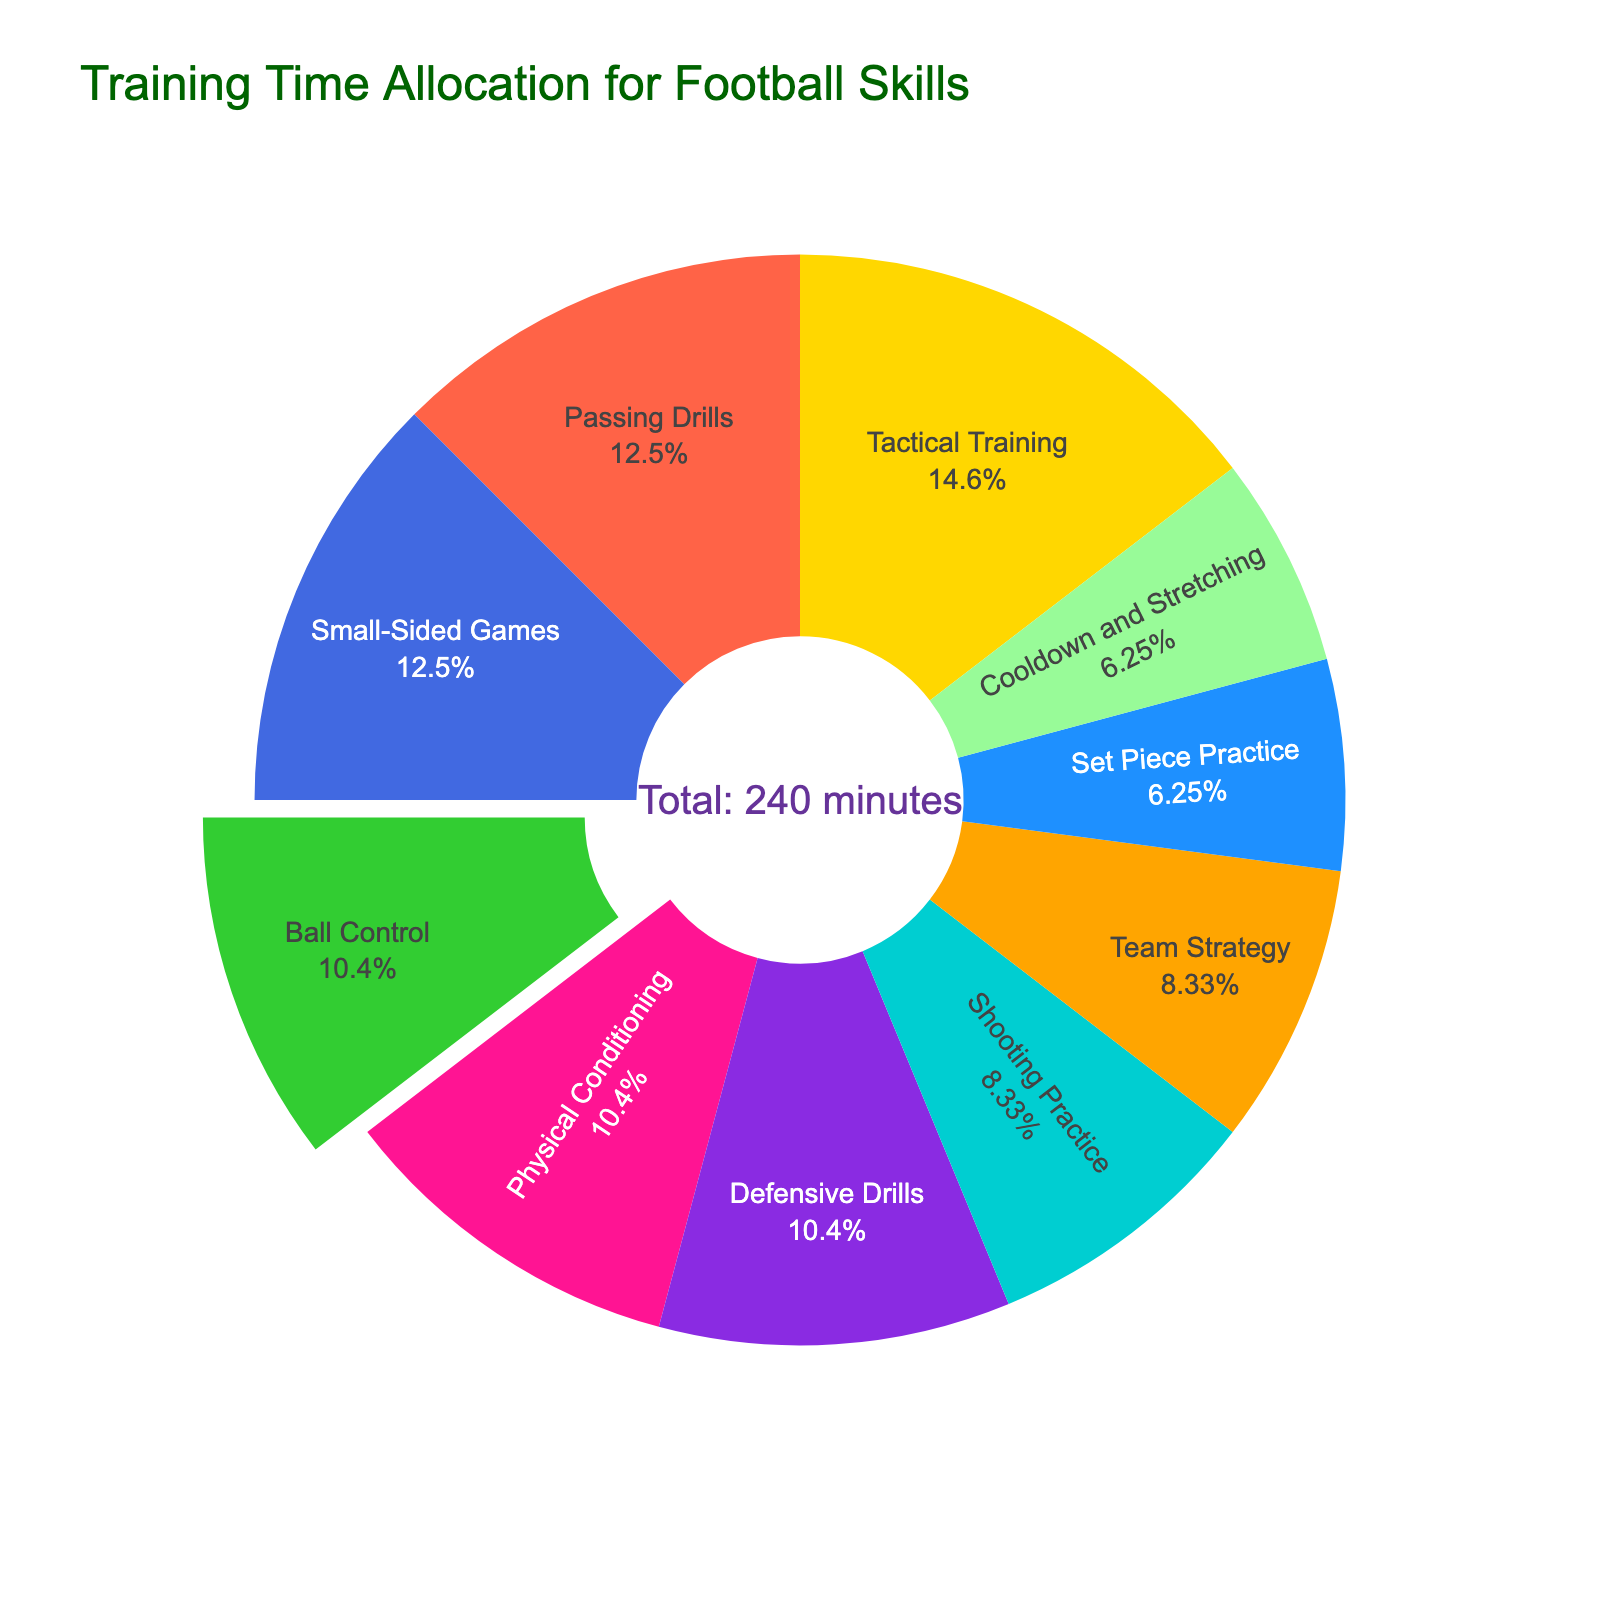Which skill has the highest allocation time? By observing the chart, the segment with the biggest area represents the skill with the highest time allocation.
Answer: Tactical Training Which two skills have equal time allocation? Looking at the chart, we observe segments of equal size corresponding to the skills of Ball Control and Defensive Drills.
Answer: Ball Control and Defensive Drills What's the total time allocated for Shooting Practice and Team Strategy? From the chart, Shooting Practice is 20 minutes and Team Strategy is 20 minutes. Summing them gives us 20 + 20 = 40 minutes.
Answer: 40 minutes How does the time allocated for Passing Drills compare to Small-Sided Games? Referring to the chart, we see the allocated time for both Passing Drills and Small-Sided Games is 30 minutes each.
Answer: Equal What percentage of training time is spent on Physical Conditioning? The chart segments denote the percentage of total time for each skill. The Physical Conditioning segment displays its percentage as part of the whole.
Answer: 10.4% What is the second least allocated skill? The chart's segment proportions identify Set Piece Practice and Cooldown and Stretching as the smallest. Among them, Set Piece Practice is higher than Cooldown and Stretching but lower than the other skills.
Answer: Cooldown and Stretching Compare the total time allocated for Ball Control and Defensive Drills with the time allocated for Tactical Training. Ball Control and Defensive Drills both have 25 minutes each, summing up to 50 minutes. Tactical Training has 35 minutes. Hence, 50 minutes (Ball Control + Defensive Drills) is greater than 35 minutes (Tactical Training).
Answer: Ball Control and Defensive Drills: 50 minutes > Tactical Training: 35 minutes Which skill is allocated 10.4% of the total training time? From the chart, noting the percentage display inside each segment, we find Physical Conditioning allocated 10.4% of the total training time.
Answer: Physical Conditioning What's the median time allocated among all skills? Listing all time allocations: 15, 15, 20, 20, 25, 25, 25, 30, 30, 35. The median is the middle value, which in this case is the average of the 5th and 6th values: (25+25)/2 = 25 minutes.
Answer: 25 minutes 